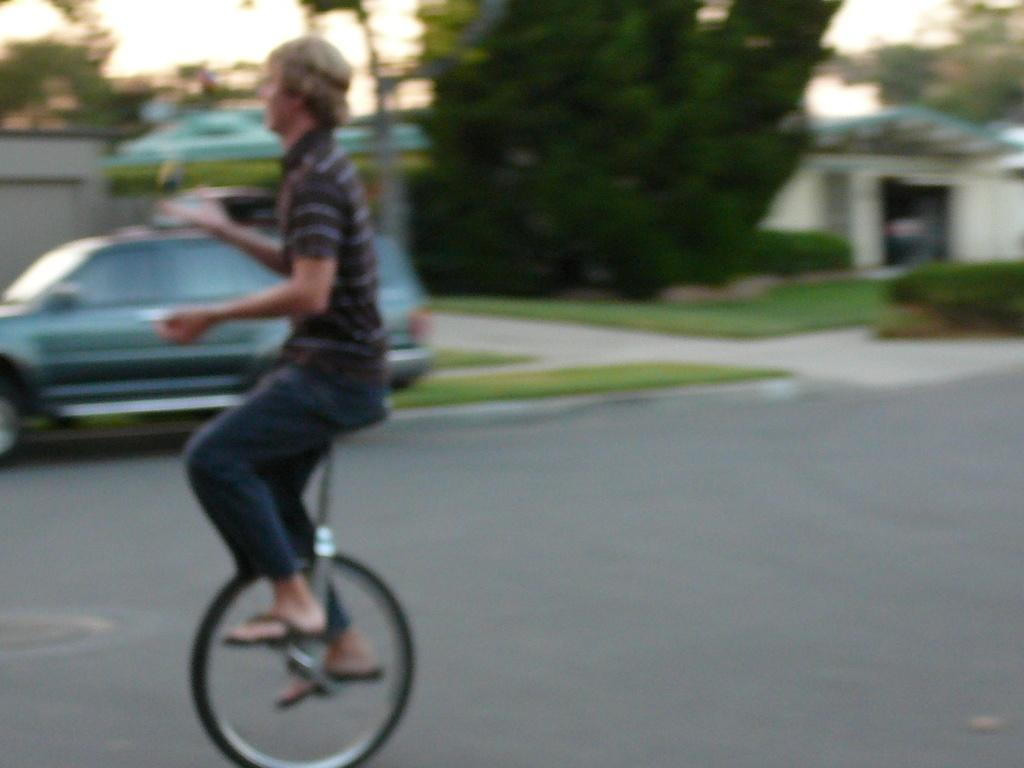What is the person in the image doing? The person is riding a unicycle in the image. How is the unicycle positioned in the image? The unicycle is placed on the ground. What can be seen in the background of the image? There is a car, a group of trees, buildings, and the sky visible in the background of the image. What type of book is the person reading while riding the unicycle in the image? There is no book present in the image, and the person is not reading while riding the unicycle. 